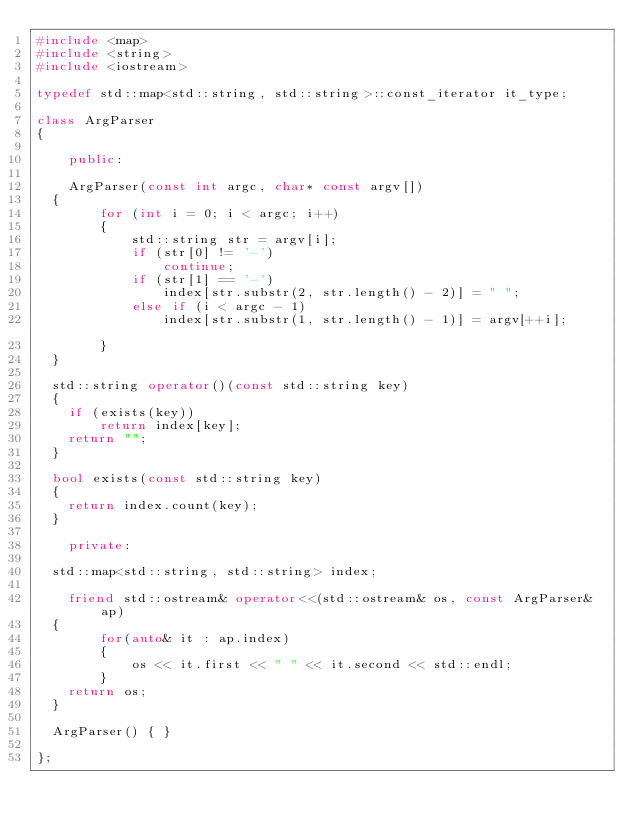Convert code to text. <code><loc_0><loc_0><loc_500><loc_500><_C++_>#include <map>
#include <string>
#include <iostream>

typedef std::map<std::string, std::string>::const_iterator it_type;

class ArgParser
{

	public:

	ArgParser(const int argc, char* const argv[])
  {
		for (int i = 0; i < argc; i++)
		{
			std::string str = argv[i]; 
			if (str[0] != '-') 
				continue;
			if (str[1] == '-')
				index[str.substr(2, str.length() - 2)] = " ";
			else if (i < argc - 1)	
				index[str.substr(1, str.length() - 1)] = argv[++i];  		
		}
  }

  std::string operator()(const std::string key)
  {
    if (exists(key)) 
    	return index[key];
    return "";	
  }
  
  bool exists(const std::string key)
  {
  	return index.count(key);
  }

	private:

  std::map<std::string, std::string> index;
	
	friend std::ostream& operator<<(std::ostream& os, const ArgParser& ap)
  {
		for(auto& it : ap.index) 
		{
			os << it.first << " " << it.second << std::endl;
		}
    return os;
  }

  ArgParser() { }
  
};
</code> 